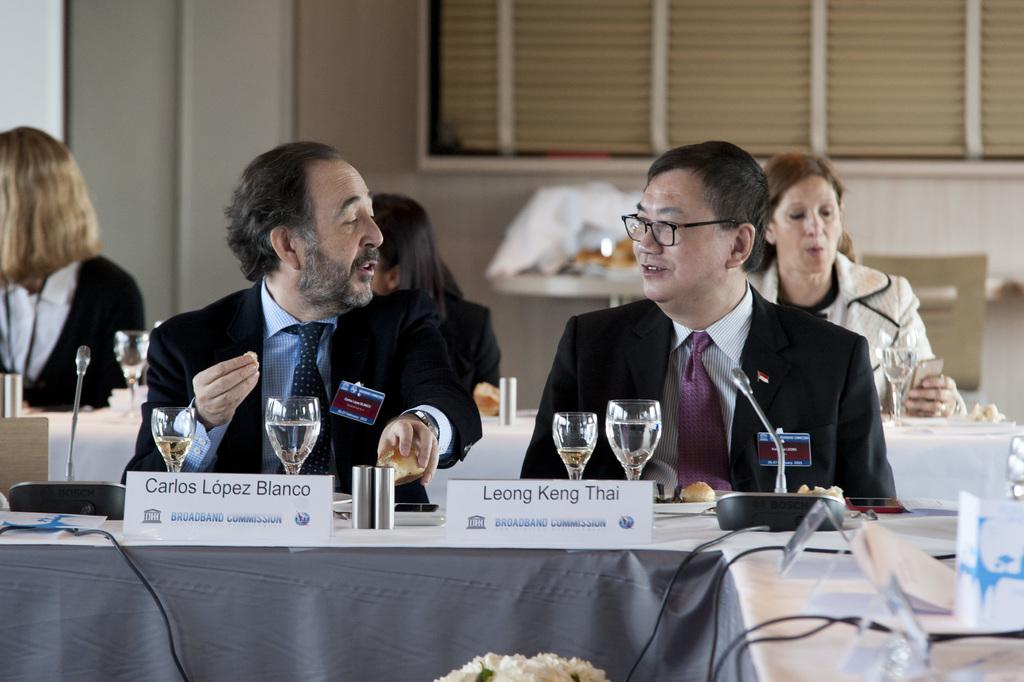<image>
Provide a brief description of the given image. Carlos Lopez Blanco sitting next to Leong Ken Thai, both wearing suits and talking over lunch. 